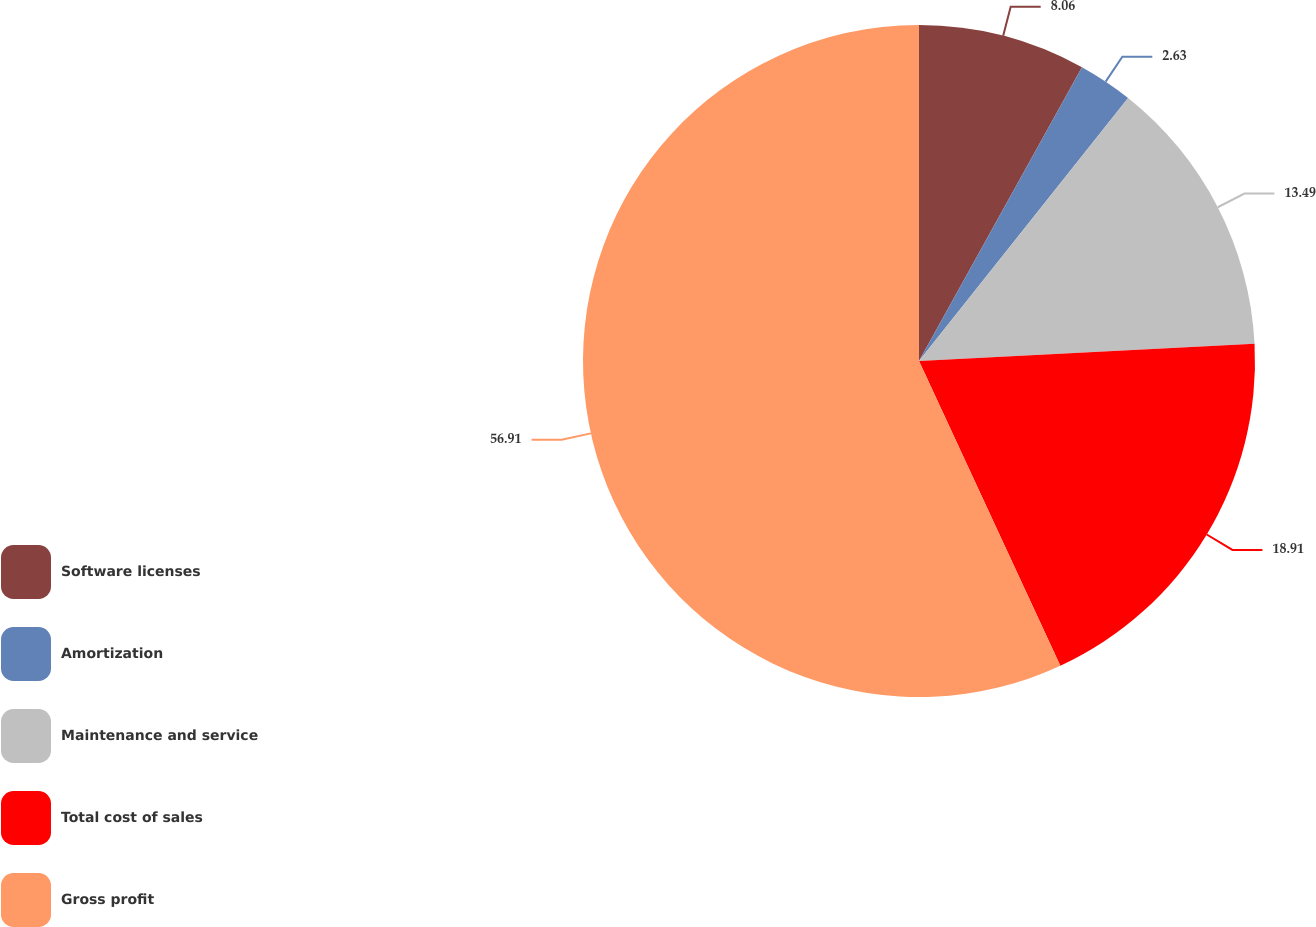Convert chart to OTSL. <chart><loc_0><loc_0><loc_500><loc_500><pie_chart><fcel>Software licenses<fcel>Amortization<fcel>Maintenance and service<fcel>Total cost of sales<fcel>Gross profit<nl><fcel>8.06%<fcel>2.63%<fcel>13.49%<fcel>18.91%<fcel>56.91%<nl></chart> 